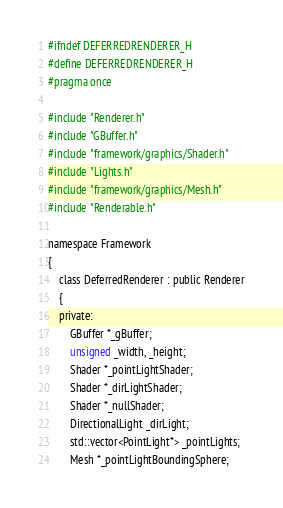Convert code to text. <code><loc_0><loc_0><loc_500><loc_500><_C_>#ifndef DEFERREDRENDERER_H
#define DEFERREDRENDERER_H
#pragma once

#include "Renderer.h"
#include "GBuffer.h"
#include "framework/graphics/Shader.h"
#include "Lights.h"
#include "framework/graphics/Mesh.h"
#include "Renderable.h"

namespace Framework
{
	class DeferredRenderer : public Renderer
	{
	private:
		GBuffer *_gBuffer;
		unsigned _width, _height;
		Shader *_pointLightShader;
		Shader *_dirLightShader;
		Shader *_nullShader;
		DirectionalLight _dirLight;
		std::vector<PointLight*> _pointLights;
		Mesh *_pointLightBoundingSphere;</code> 